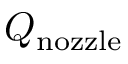<formula> <loc_0><loc_0><loc_500><loc_500>Q _ { n o z z l e }</formula> 